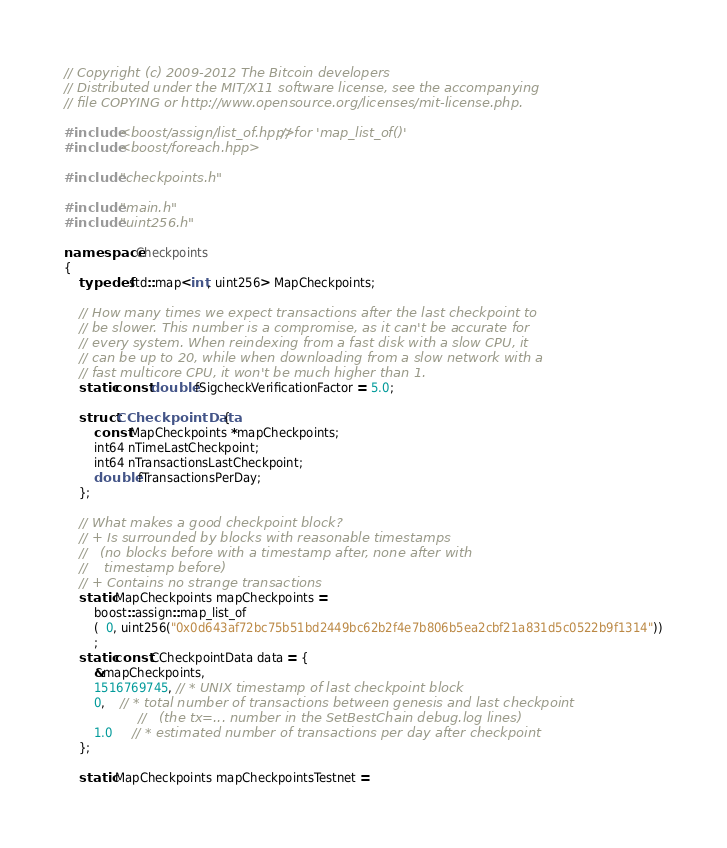Convert code to text. <code><loc_0><loc_0><loc_500><loc_500><_C++_>// Copyright (c) 2009-2012 The Bitcoin developers
// Distributed under the MIT/X11 software license, see the accompanying
// file COPYING or http://www.opensource.org/licenses/mit-license.php.

#include <boost/assign/list_of.hpp> // for 'map_list_of()'
#include <boost/foreach.hpp>

#include "checkpoints.h"

#include "main.h"
#include "uint256.h"

namespace Checkpoints
{
    typedef std::map<int, uint256> MapCheckpoints;

    // How many times we expect transactions after the last checkpoint to
    // be slower. This number is a compromise, as it can't be accurate for
    // every system. When reindexing from a fast disk with a slow CPU, it
    // can be up to 20, while when downloading from a slow network with a
    // fast multicore CPU, it won't be much higher than 1.
    static const double fSigcheckVerificationFactor = 5.0;

    struct CCheckpointData {
        const MapCheckpoints *mapCheckpoints;
        int64 nTimeLastCheckpoint;
        int64 nTransactionsLastCheckpoint;
        double fTransactionsPerDay;
    };

    // What makes a good checkpoint block?
    // + Is surrounded by blocks with reasonable timestamps
    //   (no blocks before with a timestamp after, none after with
    //    timestamp before)
    // + Contains no strange transactions
    static MapCheckpoints mapCheckpoints =
        boost::assign::map_list_of
        (  0, uint256("0x0d643af72bc75b51bd2449bc62b2f4e7b806b5ea2cbf21a831d5c0522b9f1314"))
        ;
    static const CCheckpointData data = {
        &mapCheckpoints,
        1516769745, // * UNIX timestamp of last checkpoint block
        0,    // * total number of transactions between genesis and last checkpoint
                    //   (the tx=... number in the SetBestChain debug.log lines)
        1.0     // * estimated number of transactions per day after checkpoint
    };

    static MapCheckpoints mapCheckpointsTestnet =</code> 